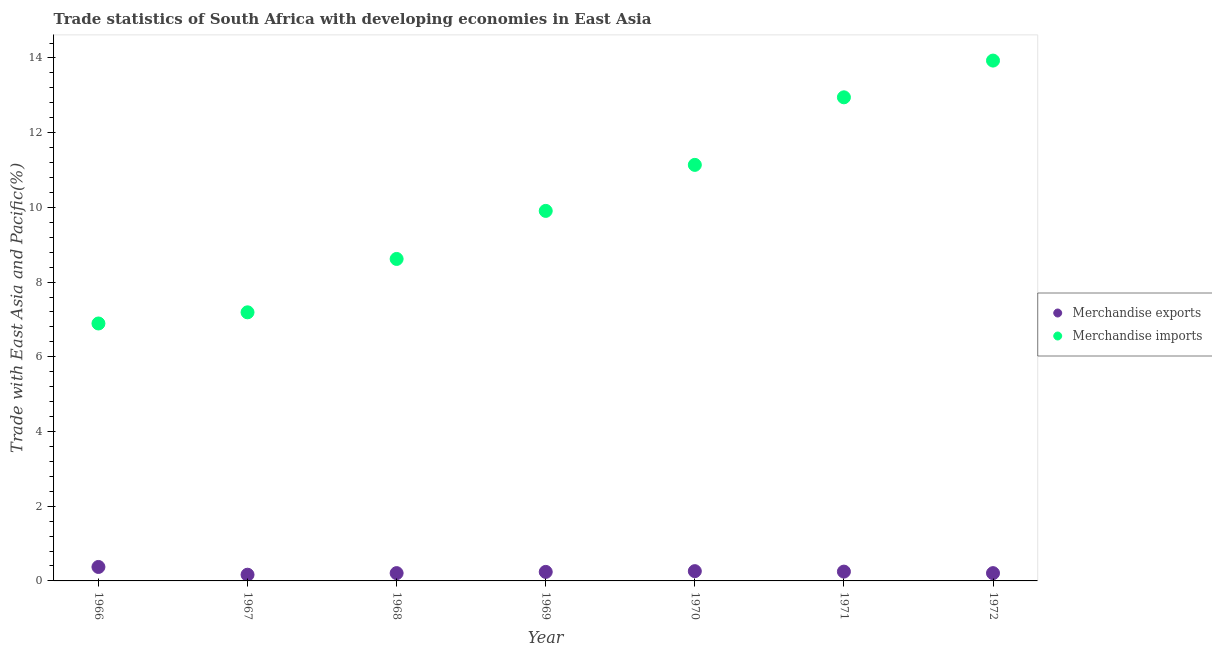How many different coloured dotlines are there?
Your response must be concise. 2. Is the number of dotlines equal to the number of legend labels?
Give a very brief answer. Yes. What is the merchandise exports in 1970?
Make the answer very short. 0.26. Across all years, what is the maximum merchandise exports?
Offer a very short reply. 0.37. Across all years, what is the minimum merchandise imports?
Provide a short and direct response. 6.89. In which year was the merchandise exports minimum?
Provide a short and direct response. 1967. What is the total merchandise imports in the graph?
Your answer should be very brief. 70.62. What is the difference between the merchandise imports in 1969 and that in 1970?
Your answer should be compact. -1.23. What is the difference between the merchandise exports in 1967 and the merchandise imports in 1971?
Offer a terse response. -12.78. What is the average merchandise imports per year?
Provide a succinct answer. 10.09. In the year 1969, what is the difference between the merchandise imports and merchandise exports?
Offer a very short reply. 9.66. What is the ratio of the merchandise exports in 1967 to that in 1969?
Offer a terse response. 0.69. Is the merchandise imports in 1966 less than that in 1971?
Give a very brief answer. Yes. What is the difference between the highest and the second highest merchandise imports?
Give a very brief answer. 0.98. What is the difference between the highest and the lowest merchandise imports?
Your response must be concise. 7.04. Is the sum of the merchandise exports in 1971 and 1972 greater than the maximum merchandise imports across all years?
Provide a short and direct response. No. Does the merchandise exports monotonically increase over the years?
Make the answer very short. No. Is the merchandise imports strictly greater than the merchandise exports over the years?
Your answer should be very brief. Yes. Is the merchandise exports strictly less than the merchandise imports over the years?
Keep it short and to the point. Yes. What is the difference between two consecutive major ticks on the Y-axis?
Provide a short and direct response. 2. Are the values on the major ticks of Y-axis written in scientific E-notation?
Provide a succinct answer. No. What is the title of the graph?
Give a very brief answer. Trade statistics of South Africa with developing economies in East Asia. What is the label or title of the Y-axis?
Your answer should be compact. Trade with East Asia and Pacific(%). What is the Trade with East Asia and Pacific(%) in Merchandise exports in 1966?
Make the answer very short. 0.37. What is the Trade with East Asia and Pacific(%) of Merchandise imports in 1966?
Ensure brevity in your answer.  6.89. What is the Trade with East Asia and Pacific(%) in Merchandise exports in 1967?
Ensure brevity in your answer.  0.17. What is the Trade with East Asia and Pacific(%) in Merchandise imports in 1967?
Give a very brief answer. 7.19. What is the Trade with East Asia and Pacific(%) in Merchandise exports in 1968?
Ensure brevity in your answer.  0.21. What is the Trade with East Asia and Pacific(%) of Merchandise imports in 1968?
Give a very brief answer. 8.62. What is the Trade with East Asia and Pacific(%) in Merchandise exports in 1969?
Your answer should be compact. 0.24. What is the Trade with East Asia and Pacific(%) in Merchandise imports in 1969?
Provide a short and direct response. 9.91. What is the Trade with East Asia and Pacific(%) in Merchandise exports in 1970?
Provide a short and direct response. 0.26. What is the Trade with East Asia and Pacific(%) in Merchandise imports in 1970?
Give a very brief answer. 11.14. What is the Trade with East Asia and Pacific(%) of Merchandise exports in 1971?
Provide a short and direct response. 0.25. What is the Trade with East Asia and Pacific(%) in Merchandise imports in 1971?
Keep it short and to the point. 12.95. What is the Trade with East Asia and Pacific(%) in Merchandise exports in 1972?
Keep it short and to the point. 0.21. What is the Trade with East Asia and Pacific(%) of Merchandise imports in 1972?
Make the answer very short. 13.93. Across all years, what is the maximum Trade with East Asia and Pacific(%) in Merchandise exports?
Your answer should be very brief. 0.37. Across all years, what is the maximum Trade with East Asia and Pacific(%) of Merchandise imports?
Give a very brief answer. 13.93. Across all years, what is the minimum Trade with East Asia and Pacific(%) of Merchandise exports?
Your answer should be compact. 0.17. Across all years, what is the minimum Trade with East Asia and Pacific(%) of Merchandise imports?
Your answer should be very brief. 6.89. What is the total Trade with East Asia and Pacific(%) in Merchandise exports in the graph?
Your answer should be compact. 1.71. What is the total Trade with East Asia and Pacific(%) in Merchandise imports in the graph?
Give a very brief answer. 70.62. What is the difference between the Trade with East Asia and Pacific(%) of Merchandise exports in 1966 and that in 1967?
Ensure brevity in your answer.  0.21. What is the difference between the Trade with East Asia and Pacific(%) in Merchandise imports in 1966 and that in 1967?
Your answer should be compact. -0.3. What is the difference between the Trade with East Asia and Pacific(%) in Merchandise exports in 1966 and that in 1968?
Make the answer very short. 0.17. What is the difference between the Trade with East Asia and Pacific(%) of Merchandise imports in 1966 and that in 1968?
Give a very brief answer. -1.73. What is the difference between the Trade with East Asia and Pacific(%) in Merchandise exports in 1966 and that in 1969?
Ensure brevity in your answer.  0.13. What is the difference between the Trade with East Asia and Pacific(%) of Merchandise imports in 1966 and that in 1969?
Your answer should be compact. -3.01. What is the difference between the Trade with East Asia and Pacific(%) in Merchandise exports in 1966 and that in 1970?
Provide a succinct answer. 0.11. What is the difference between the Trade with East Asia and Pacific(%) of Merchandise imports in 1966 and that in 1970?
Your answer should be compact. -4.25. What is the difference between the Trade with East Asia and Pacific(%) in Merchandise exports in 1966 and that in 1971?
Your response must be concise. 0.12. What is the difference between the Trade with East Asia and Pacific(%) of Merchandise imports in 1966 and that in 1971?
Make the answer very short. -6.05. What is the difference between the Trade with East Asia and Pacific(%) of Merchandise exports in 1966 and that in 1972?
Offer a very short reply. 0.17. What is the difference between the Trade with East Asia and Pacific(%) of Merchandise imports in 1966 and that in 1972?
Your answer should be compact. -7.04. What is the difference between the Trade with East Asia and Pacific(%) in Merchandise exports in 1967 and that in 1968?
Provide a short and direct response. -0.04. What is the difference between the Trade with East Asia and Pacific(%) in Merchandise imports in 1967 and that in 1968?
Keep it short and to the point. -1.43. What is the difference between the Trade with East Asia and Pacific(%) of Merchandise exports in 1967 and that in 1969?
Your answer should be very brief. -0.08. What is the difference between the Trade with East Asia and Pacific(%) of Merchandise imports in 1967 and that in 1969?
Give a very brief answer. -2.72. What is the difference between the Trade with East Asia and Pacific(%) in Merchandise exports in 1967 and that in 1970?
Provide a succinct answer. -0.1. What is the difference between the Trade with East Asia and Pacific(%) of Merchandise imports in 1967 and that in 1970?
Offer a very short reply. -3.95. What is the difference between the Trade with East Asia and Pacific(%) in Merchandise exports in 1967 and that in 1971?
Your answer should be very brief. -0.08. What is the difference between the Trade with East Asia and Pacific(%) in Merchandise imports in 1967 and that in 1971?
Your answer should be very brief. -5.76. What is the difference between the Trade with East Asia and Pacific(%) in Merchandise exports in 1967 and that in 1972?
Your response must be concise. -0.04. What is the difference between the Trade with East Asia and Pacific(%) of Merchandise imports in 1967 and that in 1972?
Offer a terse response. -6.74. What is the difference between the Trade with East Asia and Pacific(%) of Merchandise exports in 1968 and that in 1969?
Your answer should be very brief. -0.03. What is the difference between the Trade with East Asia and Pacific(%) in Merchandise imports in 1968 and that in 1969?
Make the answer very short. -1.29. What is the difference between the Trade with East Asia and Pacific(%) in Merchandise exports in 1968 and that in 1970?
Provide a short and direct response. -0.05. What is the difference between the Trade with East Asia and Pacific(%) of Merchandise imports in 1968 and that in 1970?
Your answer should be compact. -2.52. What is the difference between the Trade with East Asia and Pacific(%) in Merchandise exports in 1968 and that in 1971?
Provide a short and direct response. -0.04. What is the difference between the Trade with East Asia and Pacific(%) in Merchandise imports in 1968 and that in 1971?
Your answer should be very brief. -4.33. What is the difference between the Trade with East Asia and Pacific(%) in Merchandise imports in 1968 and that in 1972?
Ensure brevity in your answer.  -5.31. What is the difference between the Trade with East Asia and Pacific(%) of Merchandise exports in 1969 and that in 1970?
Offer a terse response. -0.02. What is the difference between the Trade with East Asia and Pacific(%) in Merchandise imports in 1969 and that in 1970?
Your answer should be compact. -1.23. What is the difference between the Trade with East Asia and Pacific(%) of Merchandise exports in 1969 and that in 1971?
Offer a very short reply. -0.01. What is the difference between the Trade with East Asia and Pacific(%) in Merchandise imports in 1969 and that in 1971?
Ensure brevity in your answer.  -3.04. What is the difference between the Trade with East Asia and Pacific(%) of Merchandise exports in 1969 and that in 1972?
Give a very brief answer. 0.03. What is the difference between the Trade with East Asia and Pacific(%) of Merchandise imports in 1969 and that in 1972?
Offer a very short reply. -4.02. What is the difference between the Trade with East Asia and Pacific(%) of Merchandise exports in 1970 and that in 1971?
Give a very brief answer. 0.01. What is the difference between the Trade with East Asia and Pacific(%) of Merchandise imports in 1970 and that in 1971?
Keep it short and to the point. -1.81. What is the difference between the Trade with East Asia and Pacific(%) in Merchandise exports in 1970 and that in 1972?
Your response must be concise. 0.05. What is the difference between the Trade with East Asia and Pacific(%) of Merchandise imports in 1970 and that in 1972?
Your answer should be very brief. -2.79. What is the difference between the Trade with East Asia and Pacific(%) in Merchandise exports in 1971 and that in 1972?
Your answer should be compact. 0.04. What is the difference between the Trade with East Asia and Pacific(%) in Merchandise imports in 1971 and that in 1972?
Offer a terse response. -0.98. What is the difference between the Trade with East Asia and Pacific(%) of Merchandise exports in 1966 and the Trade with East Asia and Pacific(%) of Merchandise imports in 1967?
Your answer should be very brief. -6.82. What is the difference between the Trade with East Asia and Pacific(%) of Merchandise exports in 1966 and the Trade with East Asia and Pacific(%) of Merchandise imports in 1968?
Your answer should be very brief. -8.25. What is the difference between the Trade with East Asia and Pacific(%) in Merchandise exports in 1966 and the Trade with East Asia and Pacific(%) in Merchandise imports in 1969?
Provide a short and direct response. -9.53. What is the difference between the Trade with East Asia and Pacific(%) of Merchandise exports in 1966 and the Trade with East Asia and Pacific(%) of Merchandise imports in 1970?
Your response must be concise. -10.76. What is the difference between the Trade with East Asia and Pacific(%) in Merchandise exports in 1966 and the Trade with East Asia and Pacific(%) in Merchandise imports in 1971?
Provide a short and direct response. -12.57. What is the difference between the Trade with East Asia and Pacific(%) of Merchandise exports in 1966 and the Trade with East Asia and Pacific(%) of Merchandise imports in 1972?
Your answer should be very brief. -13.56. What is the difference between the Trade with East Asia and Pacific(%) in Merchandise exports in 1967 and the Trade with East Asia and Pacific(%) in Merchandise imports in 1968?
Keep it short and to the point. -8.45. What is the difference between the Trade with East Asia and Pacific(%) in Merchandise exports in 1967 and the Trade with East Asia and Pacific(%) in Merchandise imports in 1969?
Keep it short and to the point. -9.74. What is the difference between the Trade with East Asia and Pacific(%) in Merchandise exports in 1967 and the Trade with East Asia and Pacific(%) in Merchandise imports in 1970?
Offer a terse response. -10.97. What is the difference between the Trade with East Asia and Pacific(%) in Merchandise exports in 1967 and the Trade with East Asia and Pacific(%) in Merchandise imports in 1971?
Offer a terse response. -12.78. What is the difference between the Trade with East Asia and Pacific(%) of Merchandise exports in 1967 and the Trade with East Asia and Pacific(%) of Merchandise imports in 1972?
Your response must be concise. -13.76. What is the difference between the Trade with East Asia and Pacific(%) of Merchandise exports in 1968 and the Trade with East Asia and Pacific(%) of Merchandise imports in 1969?
Give a very brief answer. -9.7. What is the difference between the Trade with East Asia and Pacific(%) of Merchandise exports in 1968 and the Trade with East Asia and Pacific(%) of Merchandise imports in 1970?
Provide a succinct answer. -10.93. What is the difference between the Trade with East Asia and Pacific(%) of Merchandise exports in 1968 and the Trade with East Asia and Pacific(%) of Merchandise imports in 1971?
Your answer should be compact. -12.74. What is the difference between the Trade with East Asia and Pacific(%) of Merchandise exports in 1968 and the Trade with East Asia and Pacific(%) of Merchandise imports in 1972?
Your answer should be very brief. -13.72. What is the difference between the Trade with East Asia and Pacific(%) in Merchandise exports in 1969 and the Trade with East Asia and Pacific(%) in Merchandise imports in 1970?
Give a very brief answer. -10.9. What is the difference between the Trade with East Asia and Pacific(%) of Merchandise exports in 1969 and the Trade with East Asia and Pacific(%) of Merchandise imports in 1971?
Your response must be concise. -12.71. What is the difference between the Trade with East Asia and Pacific(%) of Merchandise exports in 1969 and the Trade with East Asia and Pacific(%) of Merchandise imports in 1972?
Offer a very short reply. -13.69. What is the difference between the Trade with East Asia and Pacific(%) in Merchandise exports in 1970 and the Trade with East Asia and Pacific(%) in Merchandise imports in 1971?
Keep it short and to the point. -12.69. What is the difference between the Trade with East Asia and Pacific(%) of Merchandise exports in 1970 and the Trade with East Asia and Pacific(%) of Merchandise imports in 1972?
Ensure brevity in your answer.  -13.67. What is the difference between the Trade with East Asia and Pacific(%) of Merchandise exports in 1971 and the Trade with East Asia and Pacific(%) of Merchandise imports in 1972?
Give a very brief answer. -13.68. What is the average Trade with East Asia and Pacific(%) in Merchandise exports per year?
Your answer should be compact. 0.24. What is the average Trade with East Asia and Pacific(%) in Merchandise imports per year?
Ensure brevity in your answer.  10.09. In the year 1966, what is the difference between the Trade with East Asia and Pacific(%) of Merchandise exports and Trade with East Asia and Pacific(%) of Merchandise imports?
Your response must be concise. -6.52. In the year 1967, what is the difference between the Trade with East Asia and Pacific(%) of Merchandise exports and Trade with East Asia and Pacific(%) of Merchandise imports?
Keep it short and to the point. -7.02. In the year 1968, what is the difference between the Trade with East Asia and Pacific(%) in Merchandise exports and Trade with East Asia and Pacific(%) in Merchandise imports?
Your response must be concise. -8.41. In the year 1969, what is the difference between the Trade with East Asia and Pacific(%) of Merchandise exports and Trade with East Asia and Pacific(%) of Merchandise imports?
Ensure brevity in your answer.  -9.66. In the year 1970, what is the difference between the Trade with East Asia and Pacific(%) of Merchandise exports and Trade with East Asia and Pacific(%) of Merchandise imports?
Your answer should be very brief. -10.88. In the year 1971, what is the difference between the Trade with East Asia and Pacific(%) of Merchandise exports and Trade with East Asia and Pacific(%) of Merchandise imports?
Offer a terse response. -12.7. In the year 1972, what is the difference between the Trade with East Asia and Pacific(%) in Merchandise exports and Trade with East Asia and Pacific(%) in Merchandise imports?
Offer a terse response. -13.72. What is the ratio of the Trade with East Asia and Pacific(%) of Merchandise exports in 1966 to that in 1967?
Your answer should be compact. 2.25. What is the ratio of the Trade with East Asia and Pacific(%) of Merchandise imports in 1966 to that in 1967?
Ensure brevity in your answer.  0.96. What is the ratio of the Trade with East Asia and Pacific(%) in Merchandise exports in 1966 to that in 1968?
Your answer should be compact. 1.79. What is the ratio of the Trade with East Asia and Pacific(%) of Merchandise imports in 1966 to that in 1968?
Offer a very short reply. 0.8. What is the ratio of the Trade with East Asia and Pacific(%) in Merchandise exports in 1966 to that in 1969?
Your answer should be compact. 1.55. What is the ratio of the Trade with East Asia and Pacific(%) of Merchandise imports in 1966 to that in 1969?
Give a very brief answer. 0.7. What is the ratio of the Trade with East Asia and Pacific(%) in Merchandise exports in 1966 to that in 1970?
Your response must be concise. 1.43. What is the ratio of the Trade with East Asia and Pacific(%) in Merchandise imports in 1966 to that in 1970?
Your response must be concise. 0.62. What is the ratio of the Trade with East Asia and Pacific(%) in Merchandise exports in 1966 to that in 1971?
Offer a very short reply. 1.5. What is the ratio of the Trade with East Asia and Pacific(%) of Merchandise imports in 1966 to that in 1971?
Make the answer very short. 0.53. What is the ratio of the Trade with East Asia and Pacific(%) in Merchandise exports in 1966 to that in 1972?
Keep it short and to the point. 1.79. What is the ratio of the Trade with East Asia and Pacific(%) of Merchandise imports in 1966 to that in 1972?
Your answer should be compact. 0.49. What is the ratio of the Trade with East Asia and Pacific(%) of Merchandise exports in 1967 to that in 1968?
Offer a terse response. 0.8. What is the ratio of the Trade with East Asia and Pacific(%) in Merchandise imports in 1967 to that in 1968?
Your answer should be very brief. 0.83. What is the ratio of the Trade with East Asia and Pacific(%) of Merchandise exports in 1967 to that in 1969?
Ensure brevity in your answer.  0.69. What is the ratio of the Trade with East Asia and Pacific(%) of Merchandise imports in 1967 to that in 1969?
Provide a short and direct response. 0.73. What is the ratio of the Trade with East Asia and Pacific(%) in Merchandise exports in 1967 to that in 1970?
Give a very brief answer. 0.64. What is the ratio of the Trade with East Asia and Pacific(%) of Merchandise imports in 1967 to that in 1970?
Keep it short and to the point. 0.65. What is the ratio of the Trade with East Asia and Pacific(%) in Merchandise exports in 1967 to that in 1971?
Ensure brevity in your answer.  0.67. What is the ratio of the Trade with East Asia and Pacific(%) of Merchandise imports in 1967 to that in 1971?
Ensure brevity in your answer.  0.56. What is the ratio of the Trade with East Asia and Pacific(%) of Merchandise exports in 1967 to that in 1972?
Give a very brief answer. 0.8. What is the ratio of the Trade with East Asia and Pacific(%) of Merchandise imports in 1967 to that in 1972?
Your answer should be compact. 0.52. What is the ratio of the Trade with East Asia and Pacific(%) of Merchandise exports in 1968 to that in 1969?
Your answer should be very brief. 0.86. What is the ratio of the Trade with East Asia and Pacific(%) of Merchandise imports in 1968 to that in 1969?
Offer a very short reply. 0.87. What is the ratio of the Trade with East Asia and Pacific(%) of Merchandise exports in 1968 to that in 1970?
Make the answer very short. 0.8. What is the ratio of the Trade with East Asia and Pacific(%) of Merchandise imports in 1968 to that in 1970?
Provide a succinct answer. 0.77. What is the ratio of the Trade with East Asia and Pacific(%) of Merchandise exports in 1968 to that in 1971?
Offer a very short reply. 0.84. What is the ratio of the Trade with East Asia and Pacific(%) of Merchandise imports in 1968 to that in 1971?
Offer a terse response. 0.67. What is the ratio of the Trade with East Asia and Pacific(%) in Merchandise exports in 1968 to that in 1972?
Make the answer very short. 1. What is the ratio of the Trade with East Asia and Pacific(%) in Merchandise imports in 1968 to that in 1972?
Make the answer very short. 0.62. What is the ratio of the Trade with East Asia and Pacific(%) in Merchandise exports in 1969 to that in 1970?
Your response must be concise. 0.92. What is the ratio of the Trade with East Asia and Pacific(%) in Merchandise imports in 1969 to that in 1970?
Offer a very short reply. 0.89. What is the ratio of the Trade with East Asia and Pacific(%) of Merchandise imports in 1969 to that in 1971?
Provide a short and direct response. 0.77. What is the ratio of the Trade with East Asia and Pacific(%) of Merchandise exports in 1969 to that in 1972?
Provide a short and direct response. 1.16. What is the ratio of the Trade with East Asia and Pacific(%) in Merchandise imports in 1969 to that in 1972?
Ensure brevity in your answer.  0.71. What is the ratio of the Trade with East Asia and Pacific(%) of Merchandise exports in 1970 to that in 1971?
Provide a short and direct response. 1.05. What is the ratio of the Trade with East Asia and Pacific(%) in Merchandise imports in 1970 to that in 1971?
Give a very brief answer. 0.86. What is the ratio of the Trade with East Asia and Pacific(%) in Merchandise exports in 1970 to that in 1972?
Your answer should be very brief. 1.25. What is the ratio of the Trade with East Asia and Pacific(%) in Merchandise imports in 1970 to that in 1972?
Give a very brief answer. 0.8. What is the ratio of the Trade with East Asia and Pacific(%) of Merchandise exports in 1971 to that in 1972?
Your answer should be very brief. 1.2. What is the ratio of the Trade with East Asia and Pacific(%) in Merchandise imports in 1971 to that in 1972?
Offer a very short reply. 0.93. What is the difference between the highest and the second highest Trade with East Asia and Pacific(%) of Merchandise exports?
Offer a very short reply. 0.11. What is the difference between the highest and the second highest Trade with East Asia and Pacific(%) of Merchandise imports?
Make the answer very short. 0.98. What is the difference between the highest and the lowest Trade with East Asia and Pacific(%) of Merchandise exports?
Your answer should be compact. 0.21. What is the difference between the highest and the lowest Trade with East Asia and Pacific(%) of Merchandise imports?
Offer a very short reply. 7.04. 